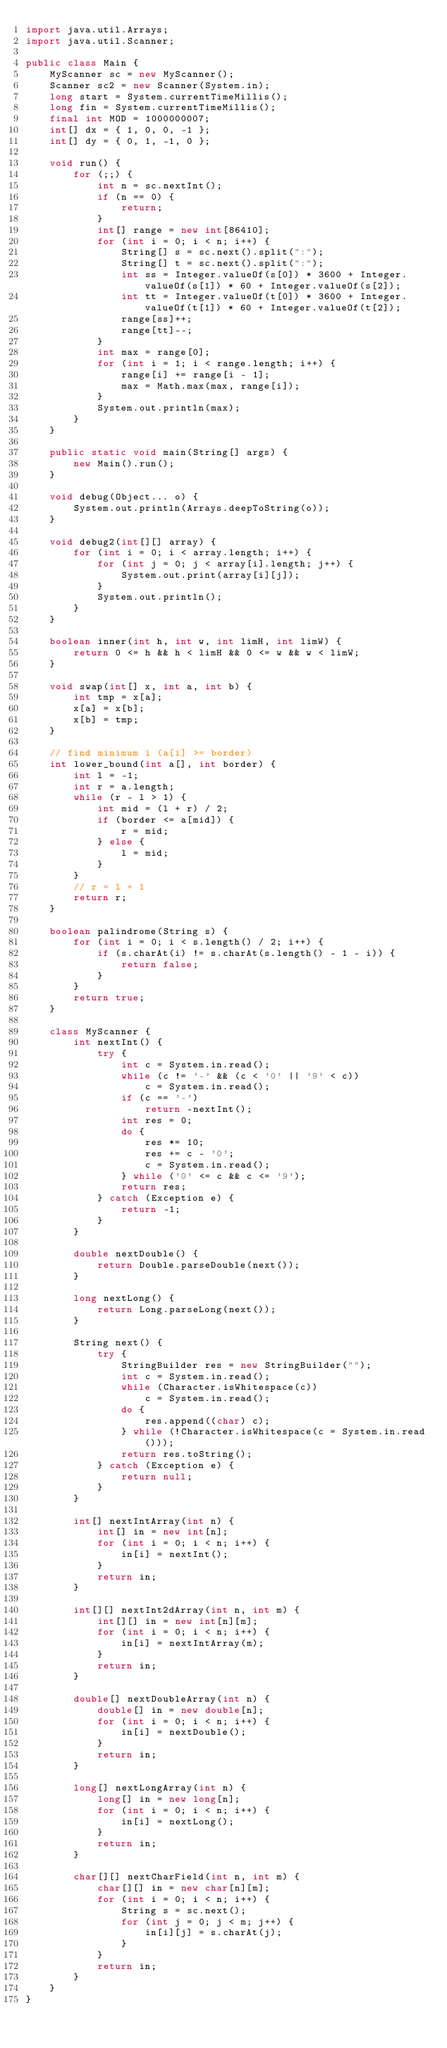<code> <loc_0><loc_0><loc_500><loc_500><_Java_>import java.util.Arrays;
import java.util.Scanner;

public class Main {
	MyScanner sc = new MyScanner();
	Scanner sc2 = new Scanner(System.in);
	long start = System.currentTimeMillis();
	long fin = System.currentTimeMillis();
	final int MOD = 1000000007;
	int[] dx = { 1, 0, 0, -1 };
	int[] dy = { 0, 1, -1, 0 };

	void run() {
		for (;;) {
			int n = sc.nextInt();
			if (n == 0) {
				return;
			}
			int[] range = new int[86410];
			for (int i = 0; i < n; i++) {
				String[] s = sc.next().split(":");
				String[] t = sc.next().split(":");
				int ss = Integer.valueOf(s[0]) * 3600 + Integer.valueOf(s[1]) * 60 + Integer.valueOf(s[2]);
				int tt = Integer.valueOf(t[0]) * 3600 + Integer.valueOf(t[1]) * 60 + Integer.valueOf(t[2]);
				range[ss]++;
				range[tt]--;
			}
			int max = range[0];
			for (int i = 1; i < range.length; i++) {
				range[i] += range[i - 1];
				max = Math.max(max, range[i]);
			}
			System.out.println(max);
		}
	}

	public static void main(String[] args) {
		new Main().run();
	}

	void debug(Object... o) {
		System.out.println(Arrays.deepToString(o));
	}

	void debug2(int[][] array) {
		for (int i = 0; i < array.length; i++) {
			for (int j = 0; j < array[i].length; j++) {
				System.out.print(array[i][j]);
			}
			System.out.println();
		}
	}

	boolean inner(int h, int w, int limH, int limW) {
		return 0 <= h && h < limH && 0 <= w && w < limW;
	}

	void swap(int[] x, int a, int b) {
		int tmp = x[a];
		x[a] = x[b];
		x[b] = tmp;
	}

	// find minimum i (a[i] >= border)
	int lower_bound(int a[], int border) {
		int l = -1;
		int r = a.length;
		while (r - l > 1) {
			int mid = (l + r) / 2;
			if (border <= a[mid]) {
				r = mid;
			} else {
				l = mid;
			}
		}
		// r = l + 1
		return r;
	}

	boolean palindrome(String s) {
		for (int i = 0; i < s.length() / 2; i++) {
			if (s.charAt(i) != s.charAt(s.length() - 1 - i)) {
				return false;
			}
		}
		return true;
	}

	class MyScanner {
		int nextInt() {
			try {
				int c = System.in.read();
				while (c != '-' && (c < '0' || '9' < c))
					c = System.in.read();
				if (c == '-')
					return -nextInt();
				int res = 0;
				do {
					res *= 10;
					res += c - '0';
					c = System.in.read();
				} while ('0' <= c && c <= '9');
				return res;
			} catch (Exception e) {
				return -1;
			}
		}

		double nextDouble() {
			return Double.parseDouble(next());
		}

		long nextLong() {
			return Long.parseLong(next());
		}

		String next() {
			try {
				StringBuilder res = new StringBuilder("");
				int c = System.in.read();
				while (Character.isWhitespace(c))
					c = System.in.read();
				do {
					res.append((char) c);
				} while (!Character.isWhitespace(c = System.in.read()));
				return res.toString();
			} catch (Exception e) {
				return null;
			}
		}

		int[] nextIntArray(int n) {
			int[] in = new int[n];
			for (int i = 0; i < n; i++) {
				in[i] = nextInt();
			}
			return in;
		}

		int[][] nextInt2dArray(int n, int m) {
			int[][] in = new int[n][m];
			for (int i = 0; i < n; i++) {
				in[i] = nextIntArray(m);
			}
			return in;
		}

		double[] nextDoubleArray(int n) {
			double[] in = new double[n];
			for (int i = 0; i < n; i++) {
				in[i] = nextDouble();
			}
			return in;
		}

		long[] nextLongArray(int n) {
			long[] in = new long[n];
			for (int i = 0; i < n; i++) {
				in[i] = nextLong();
			}
			return in;
		}

		char[][] nextCharField(int n, int m) {
			char[][] in = new char[n][m];
			for (int i = 0; i < n; i++) {
				String s = sc.next();
				for (int j = 0; j < m; j++) {
					in[i][j] = s.charAt(j);
				}
			}
			return in;
		}
	}
}</code> 